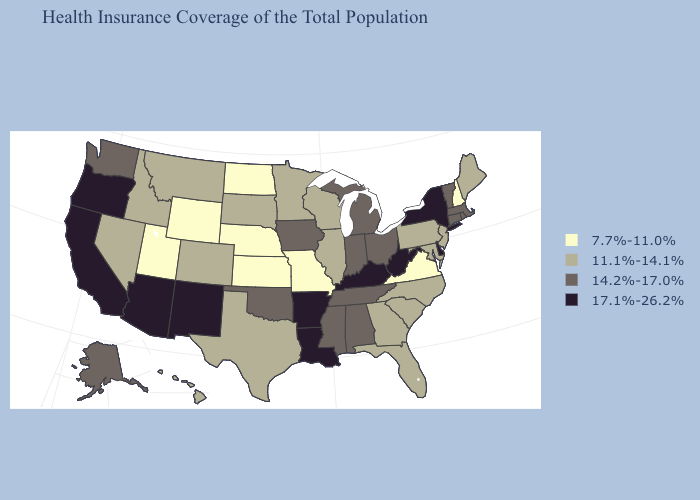Does New Mexico have the highest value in the West?
Concise answer only. Yes. What is the lowest value in the USA?
Concise answer only. 7.7%-11.0%. Name the states that have a value in the range 11.1%-14.1%?
Quick response, please. Colorado, Florida, Georgia, Hawaii, Idaho, Illinois, Maine, Maryland, Minnesota, Montana, Nevada, New Jersey, North Carolina, Pennsylvania, South Carolina, South Dakota, Texas, Wisconsin. Does the map have missing data?
Answer briefly. No. Does the first symbol in the legend represent the smallest category?
Short answer required. Yes. Does Maine have a lower value than Montana?
Short answer required. No. What is the highest value in the Northeast ?
Answer briefly. 17.1%-26.2%. How many symbols are there in the legend?
Quick response, please. 4. What is the lowest value in the West?
Concise answer only. 7.7%-11.0%. Name the states that have a value in the range 7.7%-11.0%?
Quick response, please. Kansas, Missouri, Nebraska, New Hampshire, North Dakota, Utah, Virginia, Wyoming. What is the highest value in states that border Maine?
Keep it brief. 7.7%-11.0%. What is the value of Michigan?
Answer briefly. 14.2%-17.0%. What is the value of Florida?
Give a very brief answer. 11.1%-14.1%. What is the lowest value in the USA?
Be succinct. 7.7%-11.0%. 